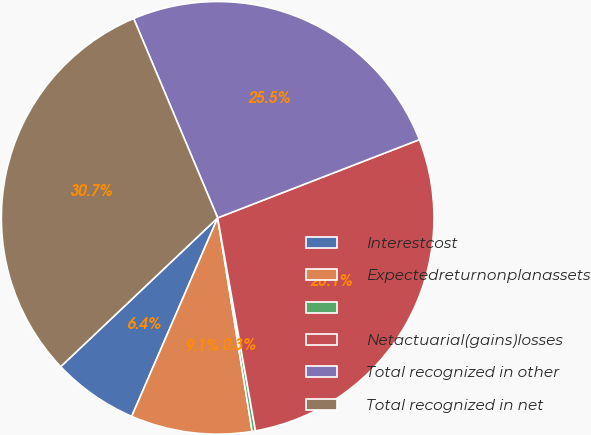Convert chart. <chart><loc_0><loc_0><loc_500><loc_500><pie_chart><fcel>Interestcost<fcel>Expectedreturnonplanassets<fcel>Unnamed: 2<fcel>Netactuarial(gains)losses<fcel>Total recognized in other<fcel>Total recognized in net<nl><fcel>6.42%<fcel>9.05%<fcel>0.25%<fcel>28.09%<fcel>25.46%<fcel>30.72%<nl></chart> 